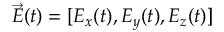Convert formula to latex. <formula><loc_0><loc_0><loc_500><loc_500>\ V e c { E } ( t ) = [ E _ { x } ( t ) , E _ { y } ( t ) , E _ { z } ( t ) ]</formula> 